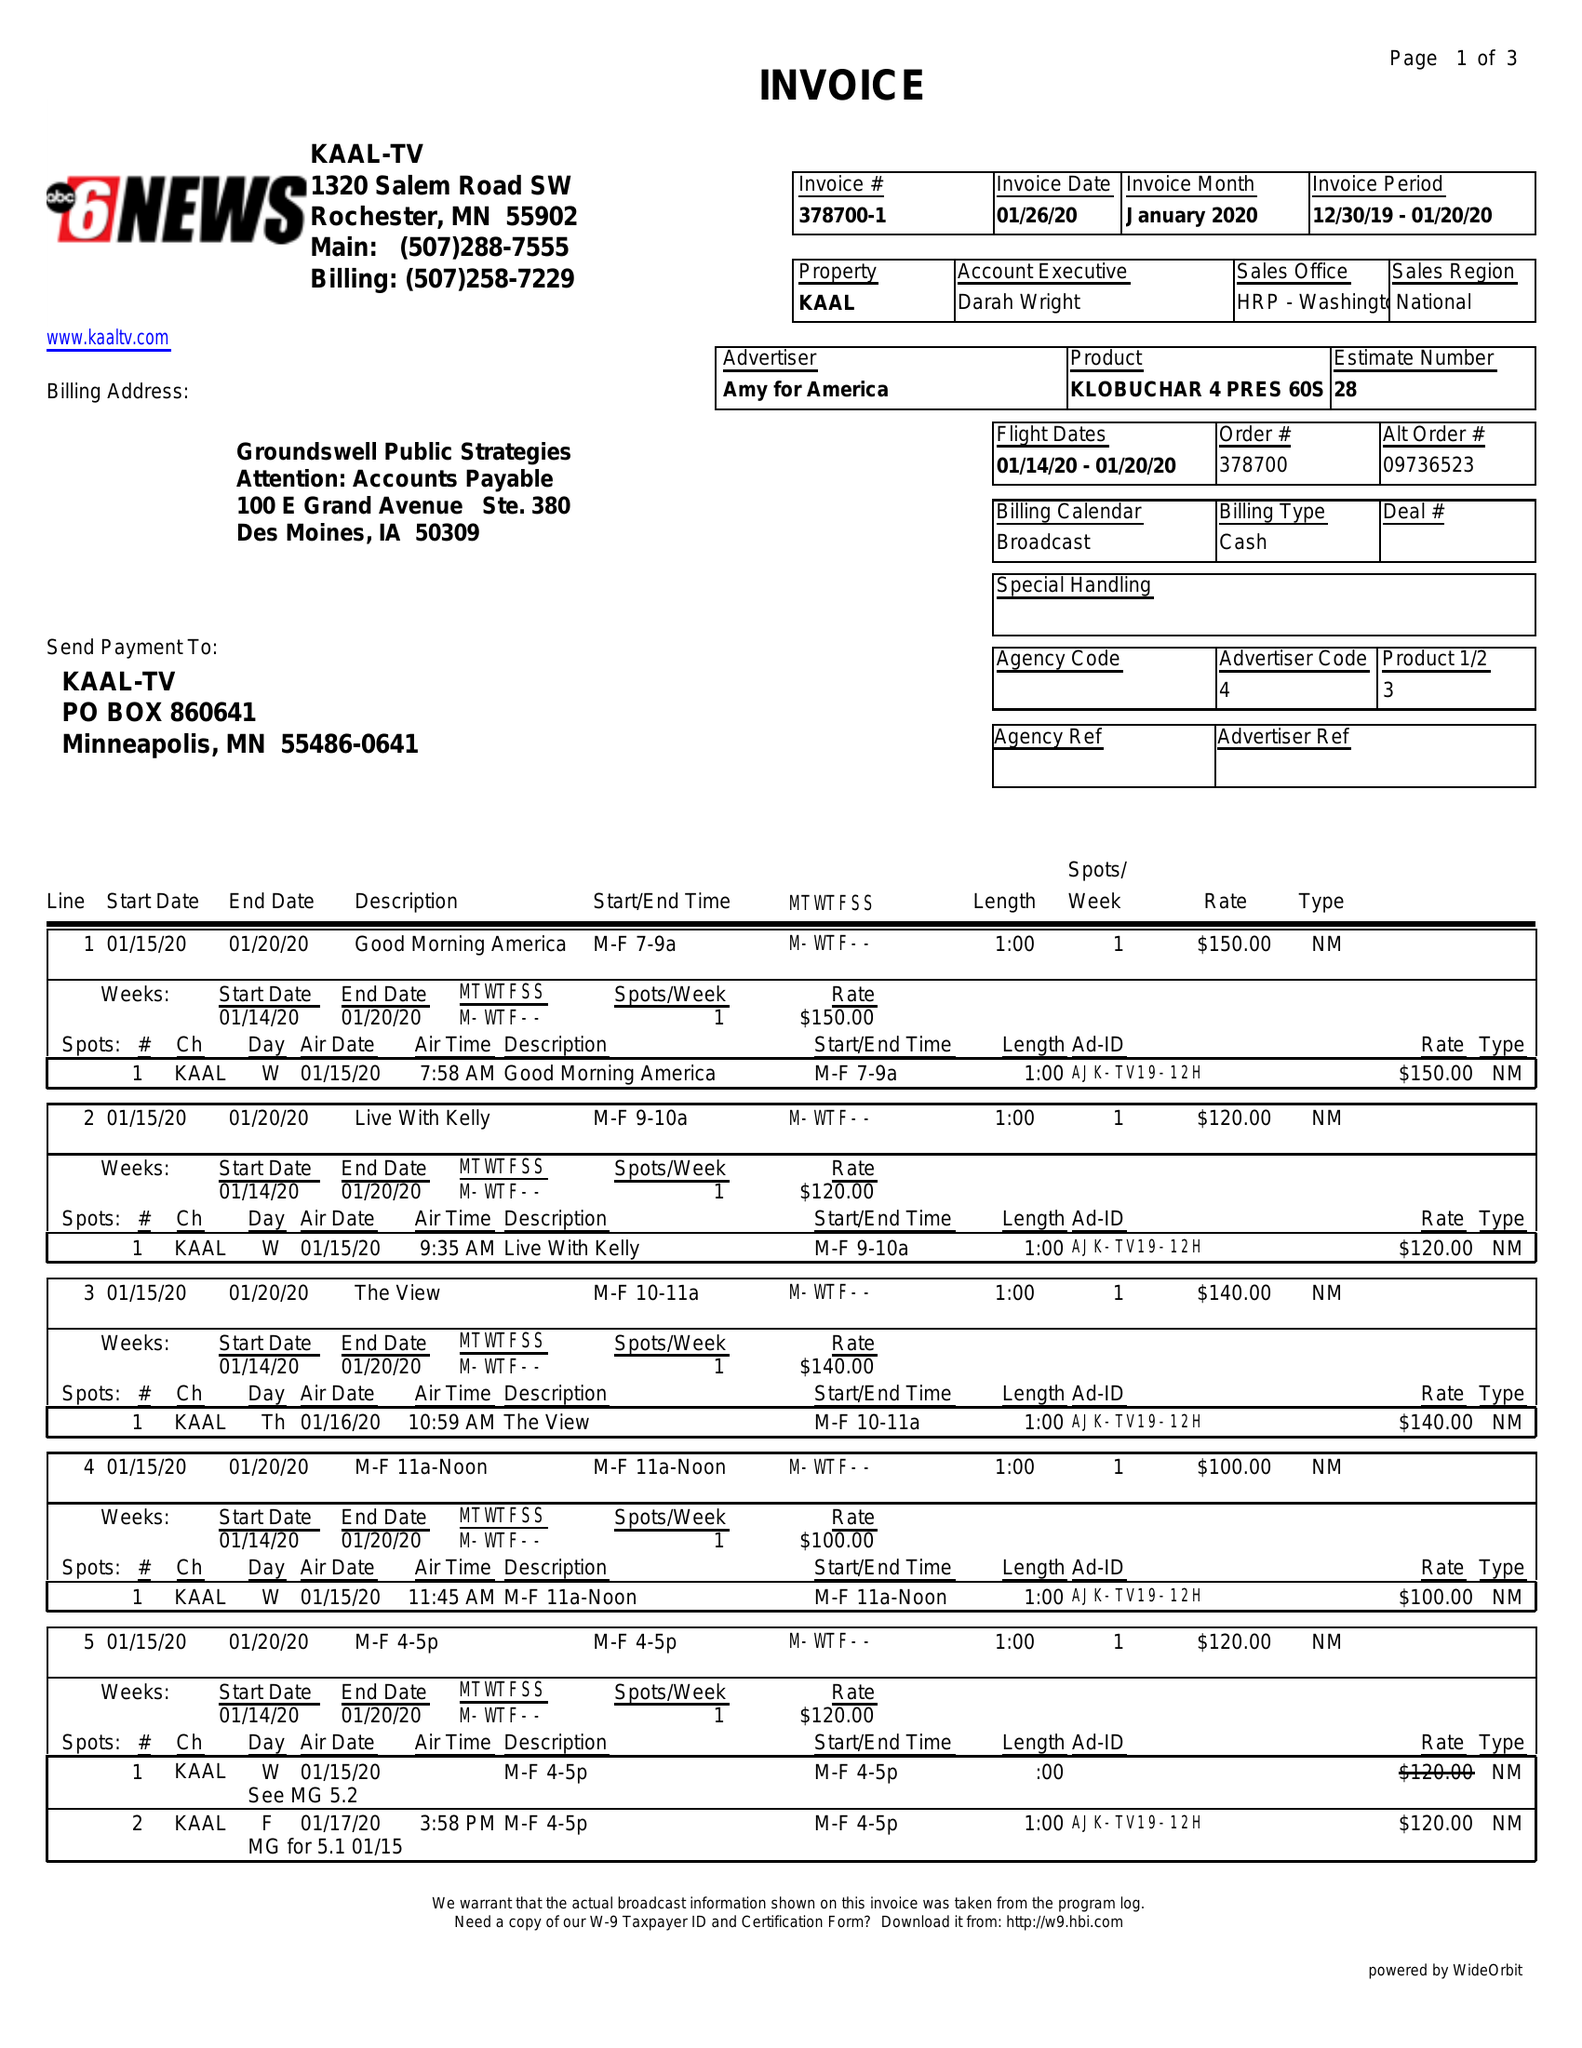What is the value for the contract_num?
Answer the question using a single word or phrase. 378700 